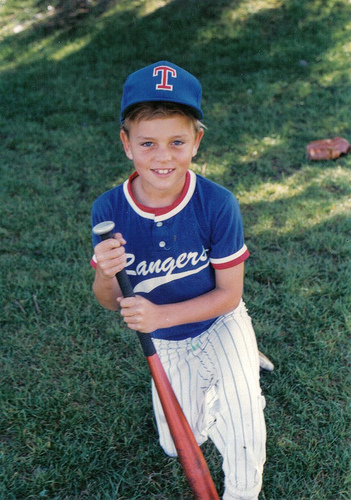Identify and read out the text in this image. T Rangers 